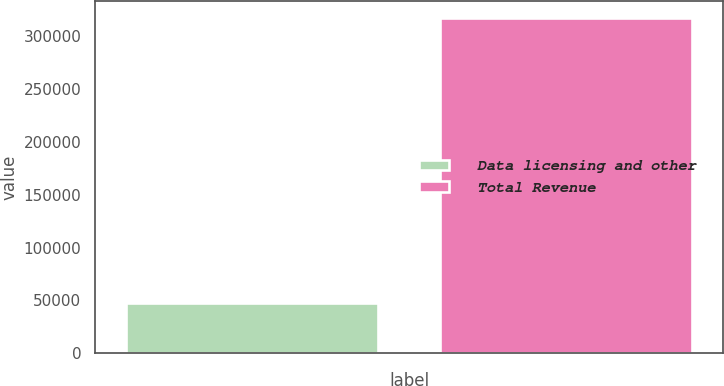Convert chart. <chart><loc_0><loc_0><loc_500><loc_500><bar_chart><fcel>Data licensing and other<fcel>Total Revenue<nl><fcel>47512<fcel>316933<nl></chart> 